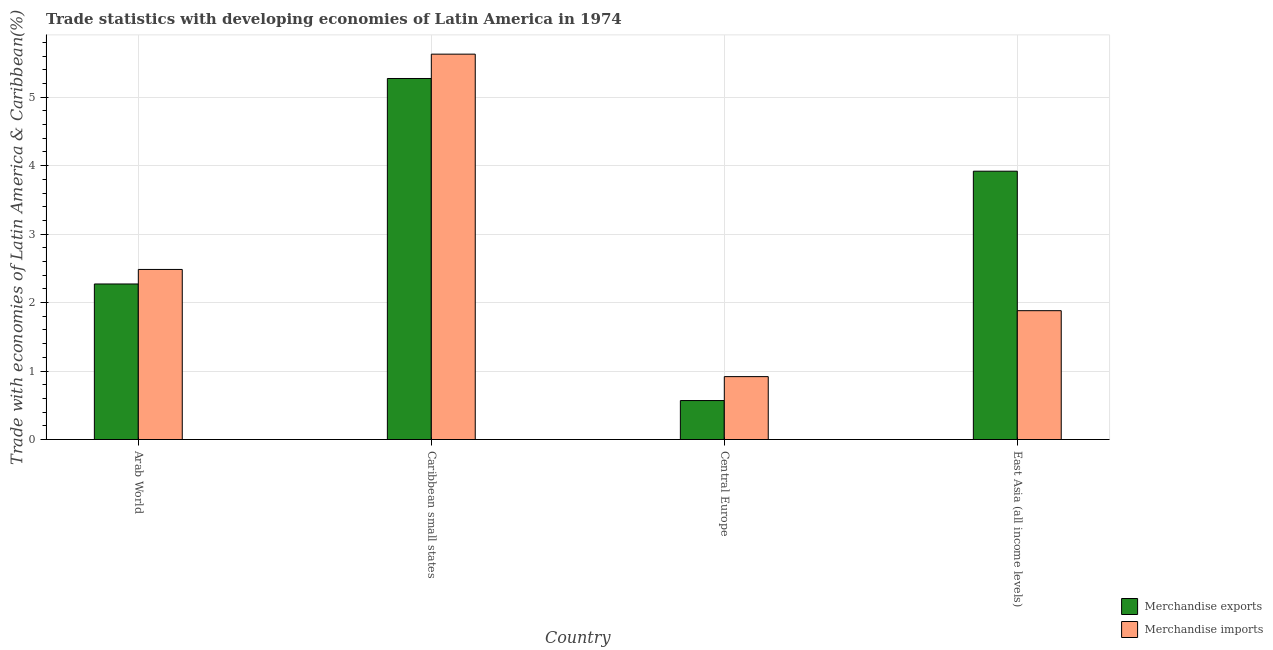How many different coloured bars are there?
Make the answer very short. 2. Are the number of bars per tick equal to the number of legend labels?
Provide a succinct answer. Yes. Are the number of bars on each tick of the X-axis equal?
Keep it short and to the point. Yes. How many bars are there on the 4th tick from the left?
Give a very brief answer. 2. What is the label of the 2nd group of bars from the left?
Provide a succinct answer. Caribbean small states. In how many cases, is the number of bars for a given country not equal to the number of legend labels?
Provide a short and direct response. 0. What is the merchandise exports in Caribbean small states?
Ensure brevity in your answer.  5.27. Across all countries, what is the maximum merchandise imports?
Give a very brief answer. 5.63. Across all countries, what is the minimum merchandise exports?
Your answer should be compact. 0.57. In which country was the merchandise imports maximum?
Your response must be concise. Caribbean small states. In which country was the merchandise imports minimum?
Give a very brief answer. Central Europe. What is the total merchandise imports in the graph?
Offer a terse response. 10.91. What is the difference between the merchandise imports in Arab World and that in Caribbean small states?
Make the answer very short. -3.14. What is the difference between the merchandise exports in East Asia (all income levels) and the merchandise imports in Arab World?
Ensure brevity in your answer.  1.44. What is the average merchandise exports per country?
Give a very brief answer. 3.01. What is the difference between the merchandise imports and merchandise exports in Arab World?
Offer a terse response. 0.21. What is the ratio of the merchandise exports in Caribbean small states to that in East Asia (all income levels)?
Your answer should be very brief. 1.35. What is the difference between the highest and the second highest merchandise exports?
Keep it short and to the point. 1.35. What is the difference between the highest and the lowest merchandise exports?
Provide a succinct answer. 4.7. In how many countries, is the merchandise exports greater than the average merchandise exports taken over all countries?
Make the answer very short. 2. What does the 2nd bar from the left in Arab World represents?
Provide a succinct answer. Merchandise imports. How many bars are there?
Offer a very short reply. 8. How many countries are there in the graph?
Your answer should be compact. 4. Where does the legend appear in the graph?
Your answer should be very brief. Bottom right. How many legend labels are there?
Provide a short and direct response. 2. How are the legend labels stacked?
Your response must be concise. Vertical. What is the title of the graph?
Your answer should be very brief. Trade statistics with developing economies of Latin America in 1974. Does "Goods and services" appear as one of the legend labels in the graph?
Keep it short and to the point. No. What is the label or title of the Y-axis?
Your answer should be very brief. Trade with economies of Latin America & Caribbean(%). What is the Trade with economies of Latin America & Caribbean(%) of Merchandise exports in Arab World?
Ensure brevity in your answer.  2.27. What is the Trade with economies of Latin America & Caribbean(%) of Merchandise imports in Arab World?
Your answer should be compact. 2.48. What is the Trade with economies of Latin America & Caribbean(%) of Merchandise exports in Caribbean small states?
Provide a succinct answer. 5.27. What is the Trade with economies of Latin America & Caribbean(%) in Merchandise imports in Caribbean small states?
Give a very brief answer. 5.63. What is the Trade with economies of Latin America & Caribbean(%) of Merchandise exports in Central Europe?
Keep it short and to the point. 0.57. What is the Trade with economies of Latin America & Caribbean(%) of Merchandise imports in Central Europe?
Provide a succinct answer. 0.92. What is the Trade with economies of Latin America & Caribbean(%) of Merchandise exports in East Asia (all income levels)?
Offer a very short reply. 3.92. What is the Trade with economies of Latin America & Caribbean(%) in Merchandise imports in East Asia (all income levels)?
Ensure brevity in your answer.  1.88. Across all countries, what is the maximum Trade with economies of Latin America & Caribbean(%) in Merchandise exports?
Offer a terse response. 5.27. Across all countries, what is the maximum Trade with economies of Latin America & Caribbean(%) in Merchandise imports?
Offer a very short reply. 5.63. Across all countries, what is the minimum Trade with economies of Latin America & Caribbean(%) of Merchandise exports?
Offer a terse response. 0.57. Across all countries, what is the minimum Trade with economies of Latin America & Caribbean(%) of Merchandise imports?
Provide a short and direct response. 0.92. What is the total Trade with economies of Latin America & Caribbean(%) in Merchandise exports in the graph?
Your response must be concise. 12.03. What is the total Trade with economies of Latin America & Caribbean(%) in Merchandise imports in the graph?
Make the answer very short. 10.91. What is the difference between the Trade with economies of Latin America & Caribbean(%) in Merchandise exports in Arab World and that in Caribbean small states?
Ensure brevity in your answer.  -3. What is the difference between the Trade with economies of Latin America & Caribbean(%) of Merchandise imports in Arab World and that in Caribbean small states?
Keep it short and to the point. -3.14. What is the difference between the Trade with economies of Latin America & Caribbean(%) in Merchandise exports in Arab World and that in Central Europe?
Keep it short and to the point. 1.7. What is the difference between the Trade with economies of Latin America & Caribbean(%) in Merchandise imports in Arab World and that in Central Europe?
Provide a short and direct response. 1.57. What is the difference between the Trade with economies of Latin America & Caribbean(%) of Merchandise exports in Arab World and that in East Asia (all income levels)?
Your answer should be very brief. -1.65. What is the difference between the Trade with economies of Latin America & Caribbean(%) in Merchandise imports in Arab World and that in East Asia (all income levels)?
Your answer should be very brief. 0.6. What is the difference between the Trade with economies of Latin America & Caribbean(%) of Merchandise exports in Caribbean small states and that in Central Europe?
Keep it short and to the point. 4.7. What is the difference between the Trade with economies of Latin America & Caribbean(%) of Merchandise imports in Caribbean small states and that in Central Europe?
Your response must be concise. 4.71. What is the difference between the Trade with economies of Latin America & Caribbean(%) of Merchandise exports in Caribbean small states and that in East Asia (all income levels)?
Provide a succinct answer. 1.35. What is the difference between the Trade with economies of Latin America & Caribbean(%) in Merchandise imports in Caribbean small states and that in East Asia (all income levels)?
Make the answer very short. 3.75. What is the difference between the Trade with economies of Latin America & Caribbean(%) in Merchandise exports in Central Europe and that in East Asia (all income levels)?
Keep it short and to the point. -3.35. What is the difference between the Trade with economies of Latin America & Caribbean(%) in Merchandise imports in Central Europe and that in East Asia (all income levels)?
Provide a succinct answer. -0.96. What is the difference between the Trade with economies of Latin America & Caribbean(%) of Merchandise exports in Arab World and the Trade with economies of Latin America & Caribbean(%) of Merchandise imports in Caribbean small states?
Offer a very short reply. -3.36. What is the difference between the Trade with economies of Latin America & Caribbean(%) in Merchandise exports in Arab World and the Trade with economies of Latin America & Caribbean(%) in Merchandise imports in Central Europe?
Provide a succinct answer. 1.35. What is the difference between the Trade with economies of Latin America & Caribbean(%) of Merchandise exports in Arab World and the Trade with economies of Latin America & Caribbean(%) of Merchandise imports in East Asia (all income levels)?
Offer a terse response. 0.39. What is the difference between the Trade with economies of Latin America & Caribbean(%) in Merchandise exports in Caribbean small states and the Trade with economies of Latin America & Caribbean(%) in Merchandise imports in Central Europe?
Make the answer very short. 4.35. What is the difference between the Trade with economies of Latin America & Caribbean(%) in Merchandise exports in Caribbean small states and the Trade with economies of Latin America & Caribbean(%) in Merchandise imports in East Asia (all income levels)?
Make the answer very short. 3.39. What is the difference between the Trade with economies of Latin America & Caribbean(%) in Merchandise exports in Central Europe and the Trade with economies of Latin America & Caribbean(%) in Merchandise imports in East Asia (all income levels)?
Your answer should be compact. -1.31. What is the average Trade with economies of Latin America & Caribbean(%) in Merchandise exports per country?
Your answer should be very brief. 3.01. What is the average Trade with economies of Latin America & Caribbean(%) of Merchandise imports per country?
Make the answer very short. 2.73. What is the difference between the Trade with economies of Latin America & Caribbean(%) of Merchandise exports and Trade with economies of Latin America & Caribbean(%) of Merchandise imports in Arab World?
Offer a very short reply. -0.21. What is the difference between the Trade with economies of Latin America & Caribbean(%) in Merchandise exports and Trade with economies of Latin America & Caribbean(%) in Merchandise imports in Caribbean small states?
Offer a very short reply. -0.36. What is the difference between the Trade with economies of Latin America & Caribbean(%) of Merchandise exports and Trade with economies of Latin America & Caribbean(%) of Merchandise imports in Central Europe?
Your answer should be very brief. -0.35. What is the difference between the Trade with economies of Latin America & Caribbean(%) in Merchandise exports and Trade with economies of Latin America & Caribbean(%) in Merchandise imports in East Asia (all income levels)?
Your answer should be compact. 2.04. What is the ratio of the Trade with economies of Latin America & Caribbean(%) in Merchandise exports in Arab World to that in Caribbean small states?
Your response must be concise. 0.43. What is the ratio of the Trade with economies of Latin America & Caribbean(%) of Merchandise imports in Arab World to that in Caribbean small states?
Offer a terse response. 0.44. What is the ratio of the Trade with economies of Latin America & Caribbean(%) of Merchandise exports in Arab World to that in Central Europe?
Ensure brevity in your answer.  3.99. What is the ratio of the Trade with economies of Latin America & Caribbean(%) of Merchandise imports in Arab World to that in Central Europe?
Make the answer very short. 2.7. What is the ratio of the Trade with economies of Latin America & Caribbean(%) in Merchandise exports in Arab World to that in East Asia (all income levels)?
Provide a short and direct response. 0.58. What is the ratio of the Trade with economies of Latin America & Caribbean(%) in Merchandise imports in Arab World to that in East Asia (all income levels)?
Ensure brevity in your answer.  1.32. What is the ratio of the Trade with economies of Latin America & Caribbean(%) in Merchandise exports in Caribbean small states to that in Central Europe?
Your answer should be very brief. 9.26. What is the ratio of the Trade with economies of Latin America & Caribbean(%) of Merchandise imports in Caribbean small states to that in Central Europe?
Provide a succinct answer. 6.13. What is the ratio of the Trade with economies of Latin America & Caribbean(%) in Merchandise exports in Caribbean small states to that in East Asia (all income levels)?
Offer a very short reply. 1.35. What is the ratio of the Trade with economies of Latin America & Caribbean(%) in Merchandise imports in Caribbean small states to that in East Asia (all income levels)?
Ensure brevity in your answer.  2.99. What is the ratio of the Trade with economies of Latin America & Caribbean(%) in Merchandise exports in Central Europe to that in East Asia (all income levels)?
Make the answer very short. 0.15. What is the ratio of the Trade with economies of Latin America & Caribbean(%) in Merchandise imports in Central Europe to that in East Asia (all income levels)?
Give a very brief answer. 0.49. What is the difference between the highest and the second highest Trade with economies of Latin America & Caribbean(%) of Merchandise exports?
Your response must be concise. 1.35. What is the difference between the highest and the second highest Trade with economies of Latin America & Caribbean(%) of Merchandise imports?
Ensure brevity in your answer.  3.14. What is the difference between the highest and the lowest Trade with economies of Latin America & Caribbean(%) of Merchandise exports?
Offer a terse response. 4.7. What is the difference between the highest and the lowest Trade with economies of Latin America & Caribbean(%) of Merchandise imports?
Provide a short and direct response. 4.71. 